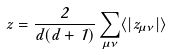Convert formula to latex. <formula><loc_0><loc_0><loc_500><loc_500>z = \frac { 2 } { d ( d + 1 ) } \sum _ { \mu \nu } \langle | z _ { \mu \nu } | \rangle</formula> 